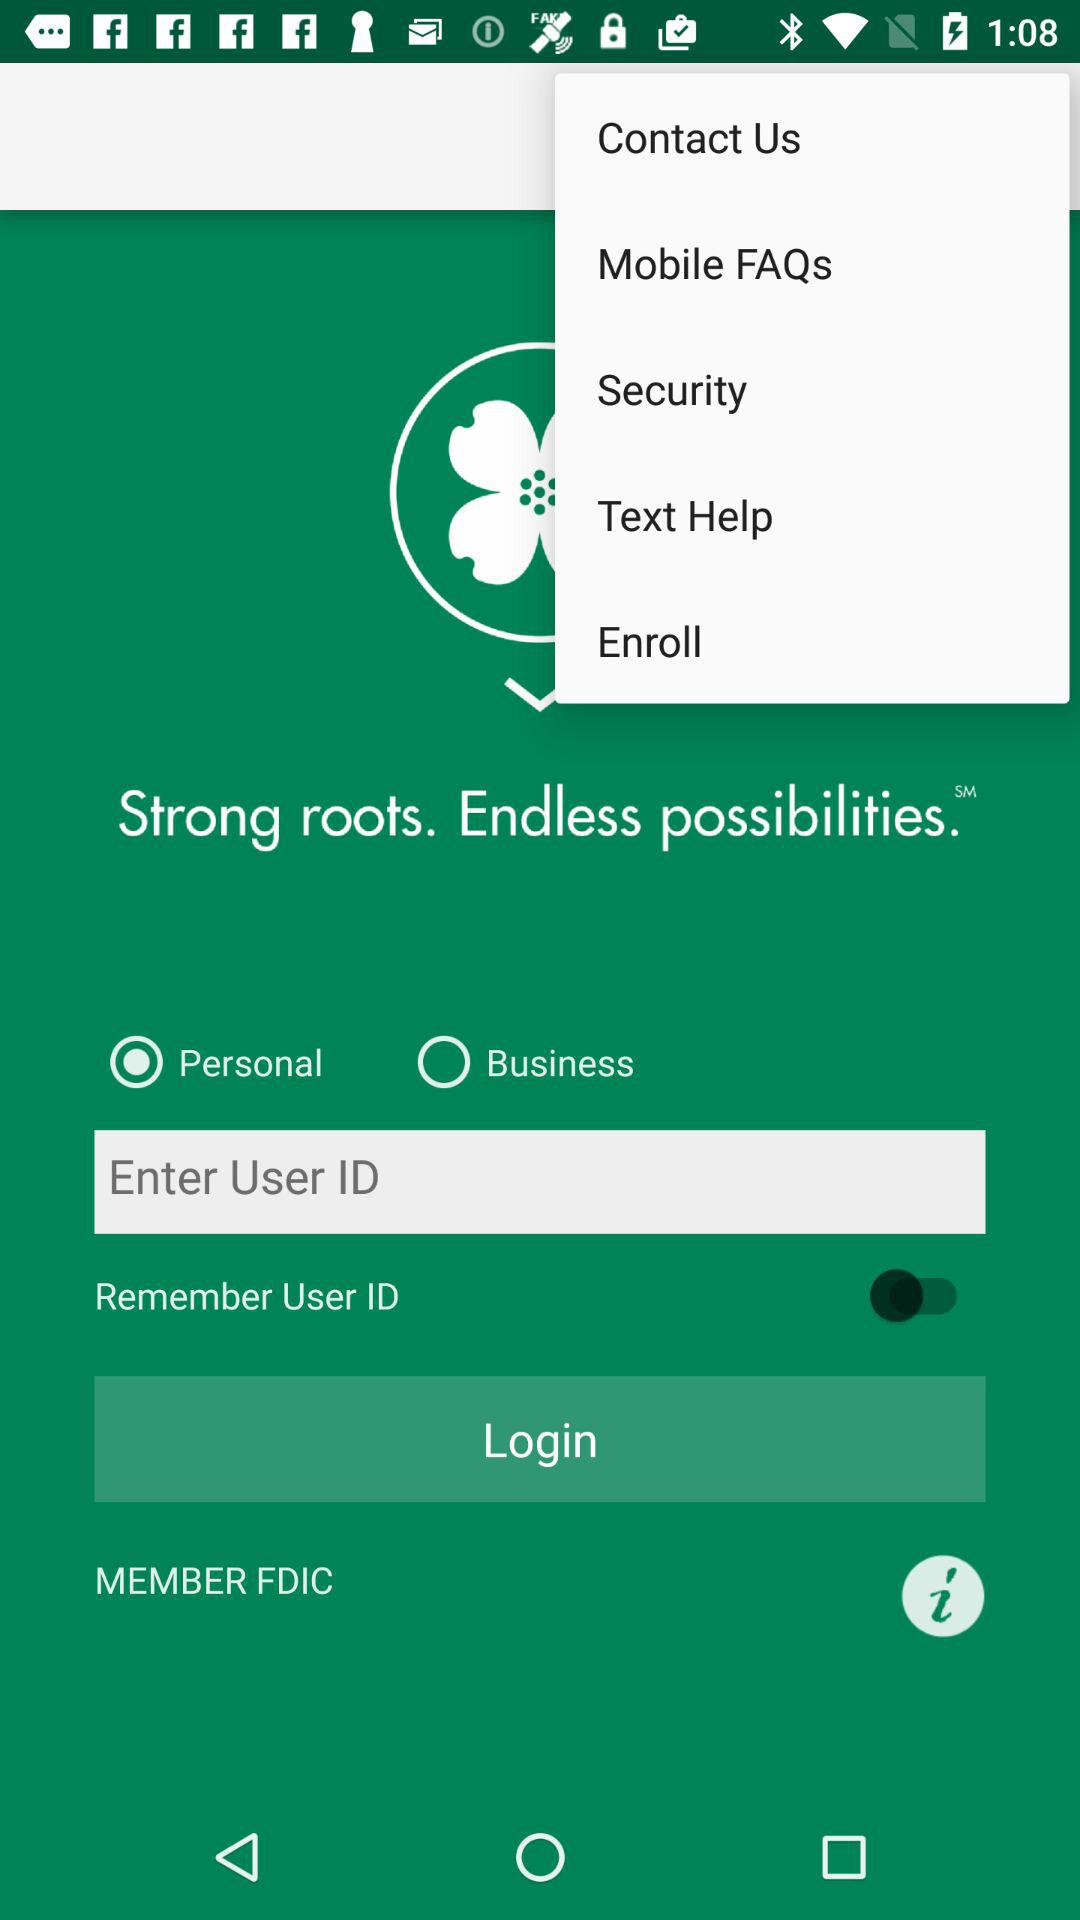Which option is selected by user? The option selected by the user is "Personal". 